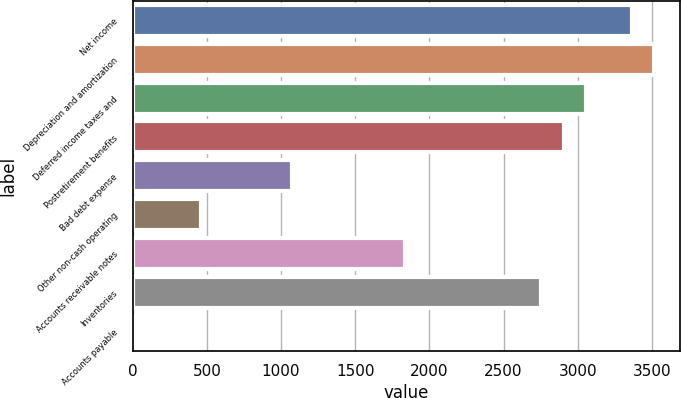Convert chart. <chart><loc_0><loc_0><loc_500><loc_500><bar_chart><fcel>Net income<fcel>Depreciation and amortization<fcel>Deferred income taxes and<fcel>Postretirement benefits<fcel>Bad debt expense<fcel>Other non-cash operating<fcel>Accounts receivable notes<fcel>Inventories<fcel>Accounts payable<nl><fcel>3363.2<fcel>3515.8<fcel>3058<fcel>2905.4<fcel>1074.2<fcel>463.8<fcel>1837.2<fcel>2752.8<fcel>6<nl></chart> 